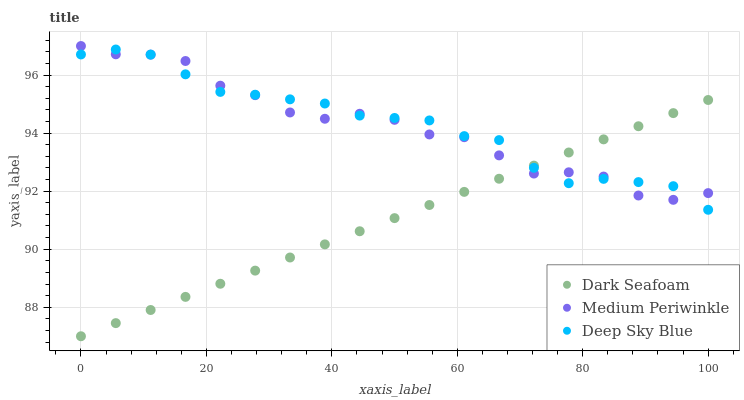Does Dark Seafoam have the minimum area under the curve?
Answer yes or no. Yes. Does Deep Sky Blue have the maximum area under the curve?
Answer yes or no. Yes. Does Medium Periwinkle have the minimum area under the curve?
Answer yes or no. No. Does Medium Periwinkle have the maximum area under the curve?
Answer yes or no. No. Is Dark Seafoam the smoothest?
Answer yes or no. Yes. Is Medium Periwinkle the roughest?
Answer yes or no. Yes. Is Deep Sky Blue the smoothest?
Answer yes or no. No. Is Deep Sky Blue the roughest?
Answer yes or no. No. Does Dark Seafoam have the lowest value?
Answer yes or no. Yes. Does Deep Sky Blue have the lowest value?
Answer yes or no. No. Does Medium Periwinkle have the highest value?
Answer yes or no. Yes. Does Deep Sky Blue have the highest value?
Answer yes or no. No. Does Dark Seafoam intersect Deep Sky Blue?
Answer yes or no. Yes. Is Dark Seafoam less than Deep Sky Blue?
Answer yes or no. No. Is Dark Seafoam greater than Deep Sky Blue?
Answer yes or no. No. 